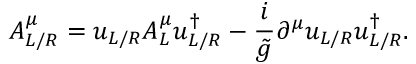Convert formula to latex. <formula><loc_0><loc_0><loc_500><loc_500>A _ { L / R } ^ { \mu } = u _ { L / R } A _ { L } ^ { \mu } u _ { L / R } ^ { \dagger } - \frac { i } { \tilde { g } } \partial ^ { \mu } u _ { L / R } u _ { L / R } ^ { \dagger } .</formula> 